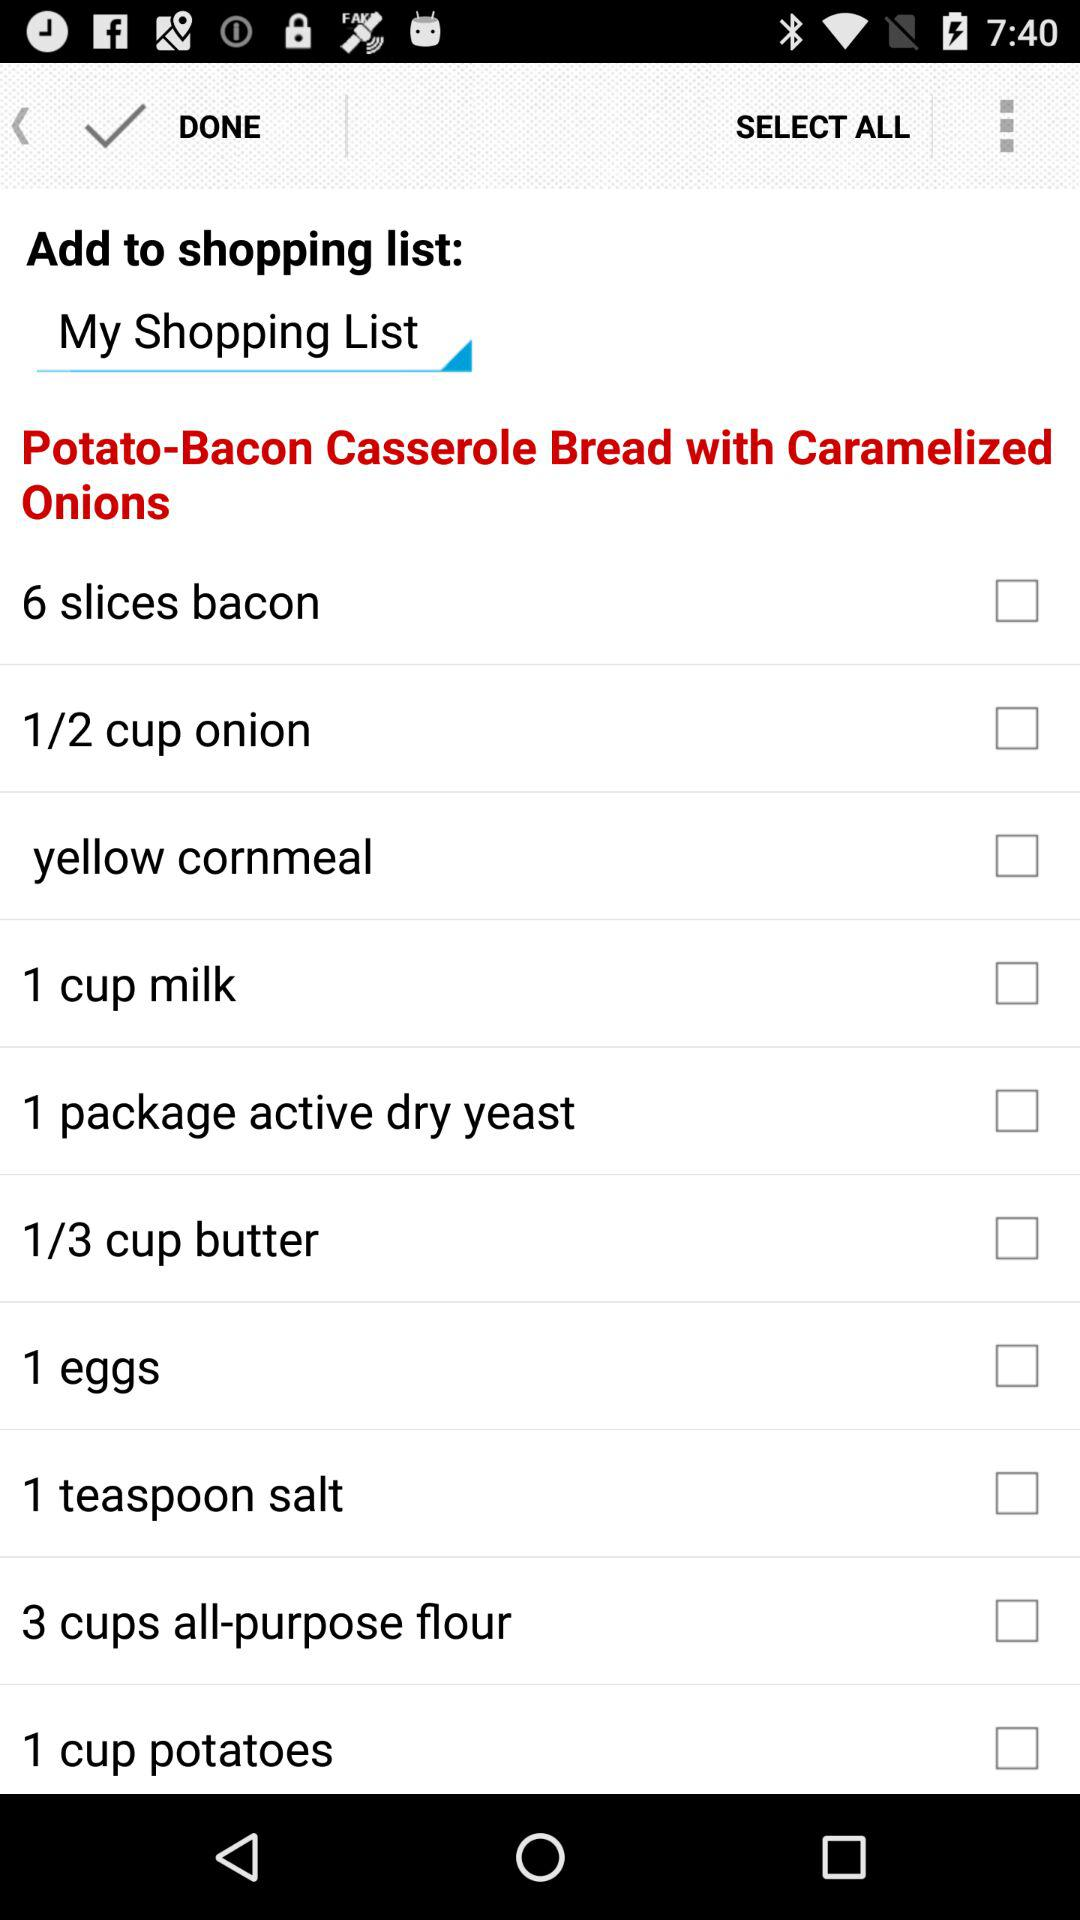What is the number of "active dry yeast"? There is 1 package of active dry yeast. 